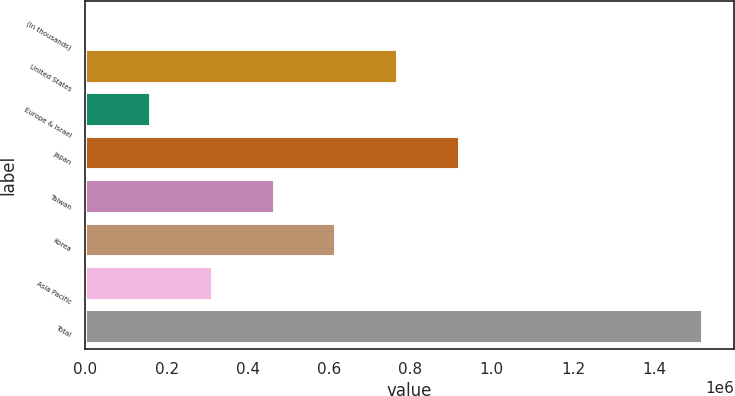<chart> <loc_0><loc_0><loc_500><loc_500><bar_chart><fcel>(In thousands)<fcel>United States<fcel>Europe & Israel<fcel>Japan<fcel>Taiwan<fcel>Korea<fcel>Asia Pacific<fcel>Total<nl><fcel>2009<fcel>769948<fcel>162665<fcel>921768<fcel>466306<fcel>618127<fcel>314486<fcel>1.52022e+06<nl></chart> 